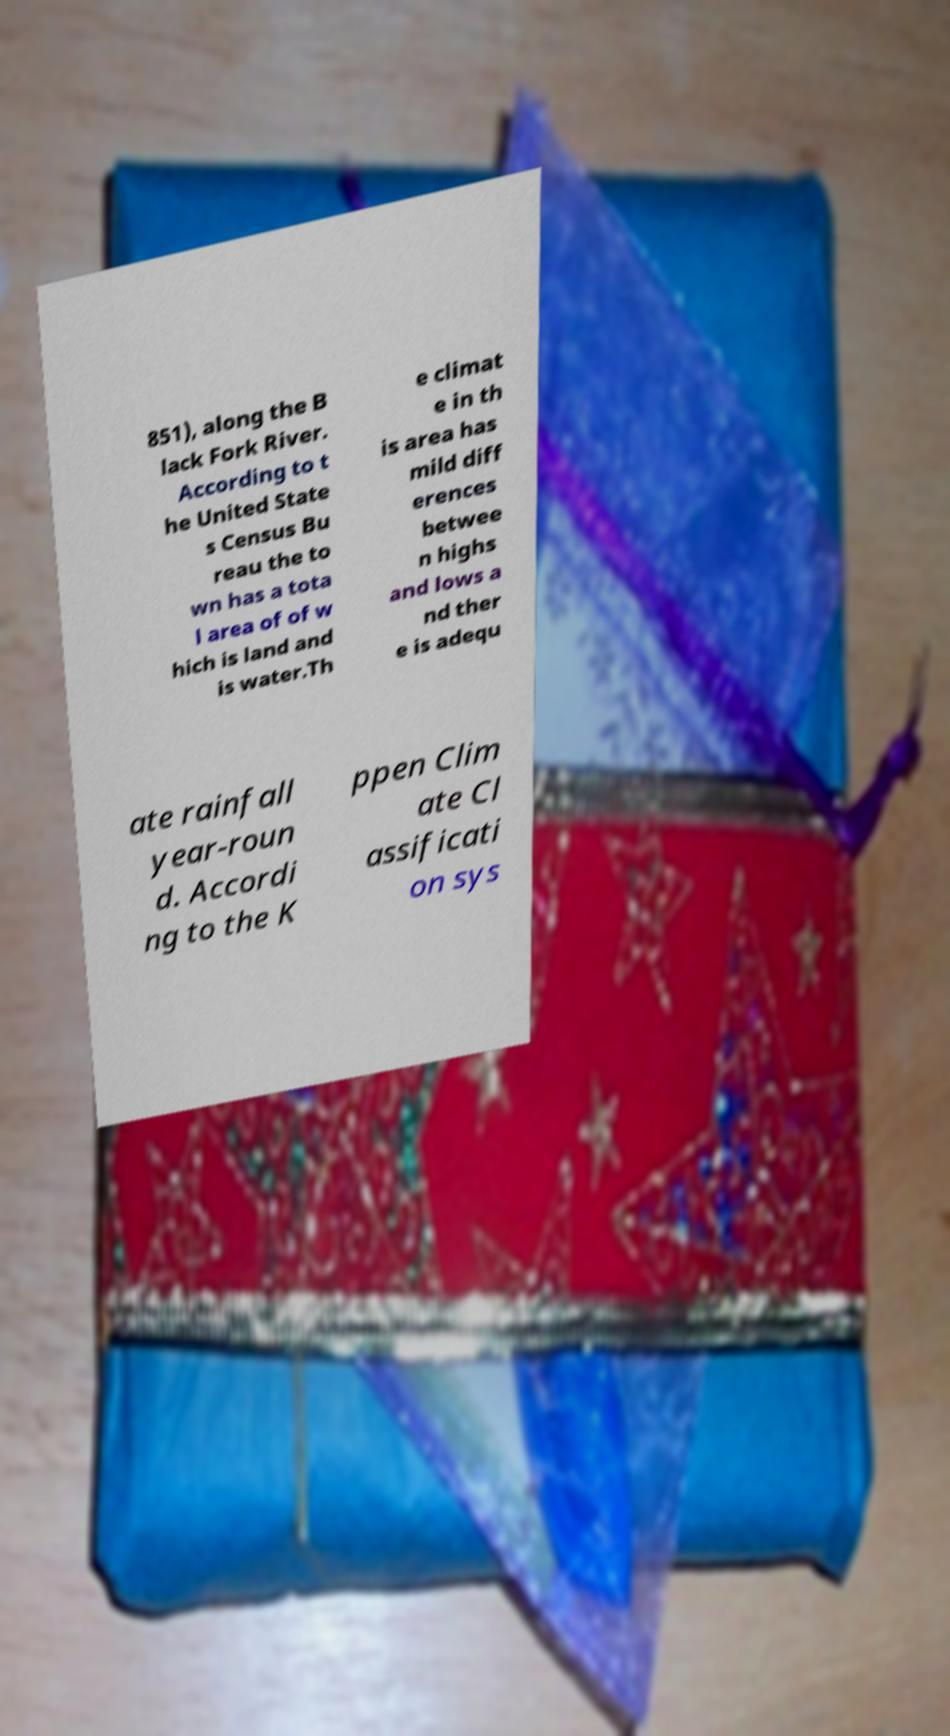Please identify and transcribe the text found in this image. 851), along the B lack Fork River. According to t he United State s Census Bu reau the to wn has a tota l area of of w hich is land and is water.Th e climat e in th is area has mild diff erences betwee n highs and lows a nd ther e is adequ ate rainfall year-roun d. Accordi ng to the K ppen Clim ate Cl assificati on sys 